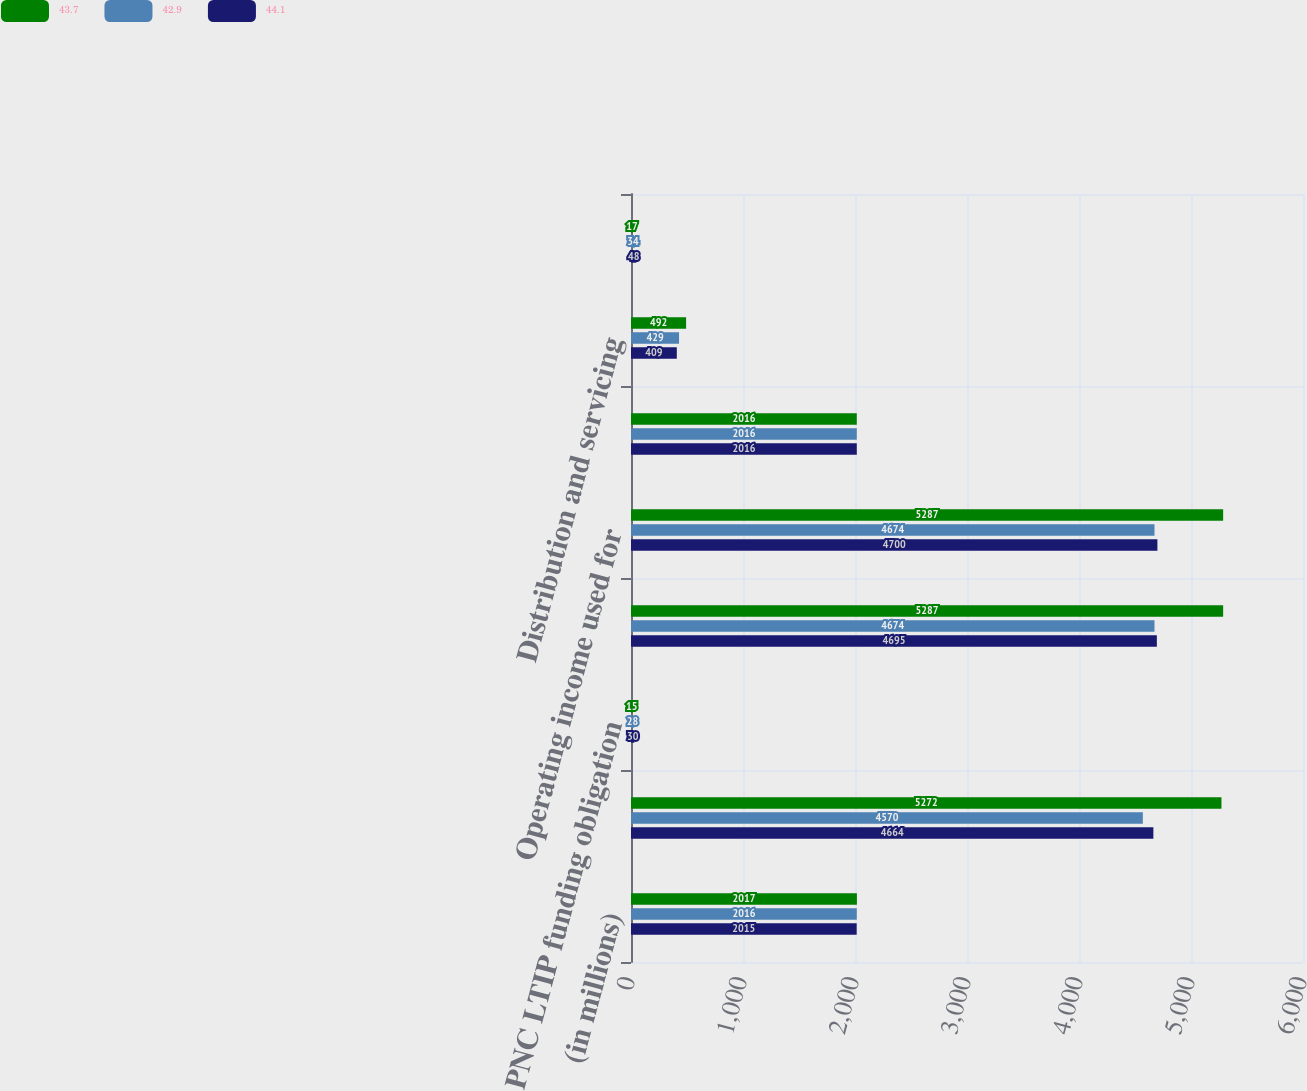<chart> <loc_0><loc_0><loc_500><loc_500><stacked_bar_chart><ecel><fcel>(in millions)<fcel>Operating income GAAP basis<fcel>PNC LTIP funding obligation<fcel>Operating income as adjusted<fcel>Operating income used for<fcel>Revenue GAAP basis<fcel>Distribution and servicing<fcel>Amortization of deferred sales<nl><fcel>43.7<fcel>2017<fcel>5272<fcel>15<fcel>5287<fcel>5287<fcel>2016<fcel>492<fcel>17<nl><fcel>42.9<fcel>2016<fcel>4570<fcel>28<fcel>4674<fcel>4674<fcel>2016<fcel>429<fcel>34<nl><fcel>44.1<fcel>2015<fcel>4664<fcel>30<fcel>4695<fcel>4700<fcel>2016<fcel>409<fcel>48<nl></chart> 